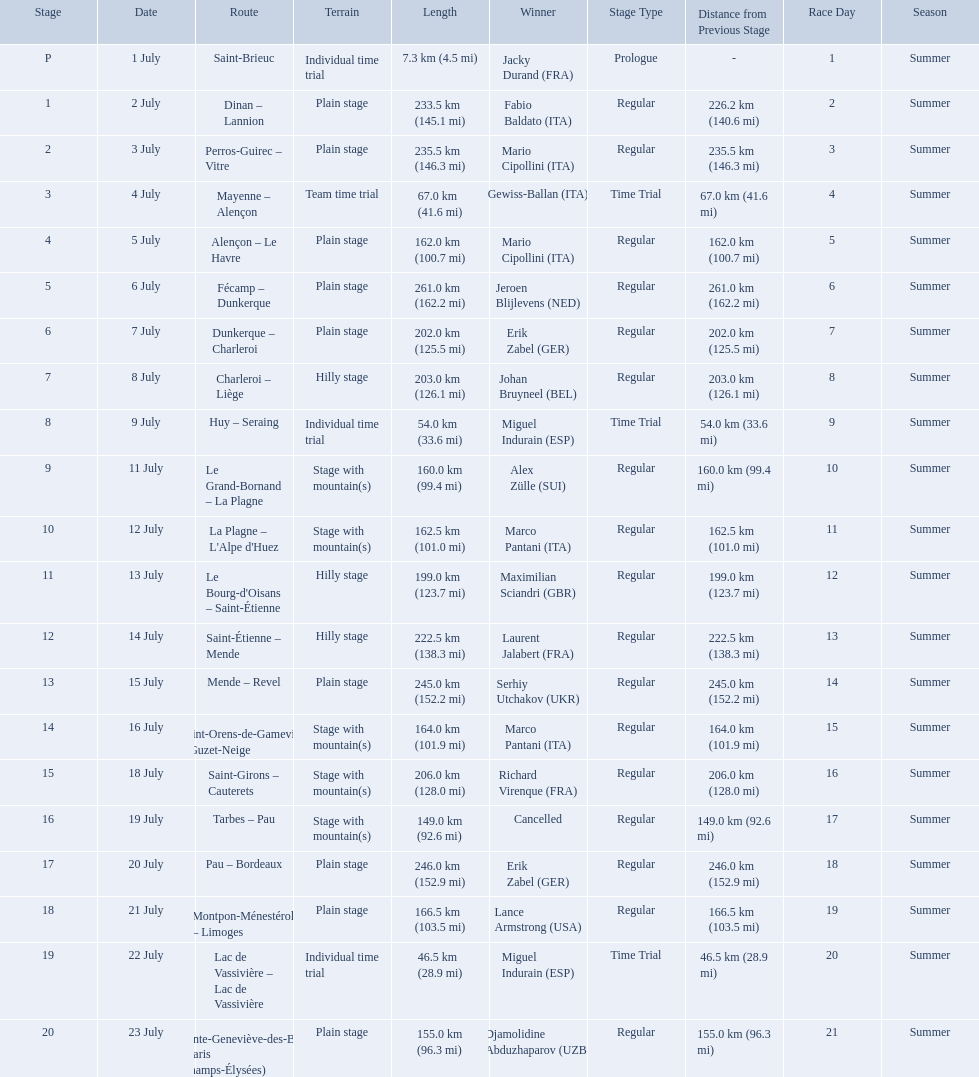What were the lengths of all the stages of the 1995 tour de france? 7.3 km (4.5 mi), 233.5 km (145.1 mi), 235.5 km (146.3 mi), 67.0 km (41.6 mi), 162.0 km (100.7 mi), 261.0 km (162.2 mi), 202.0 km (125.5 mi), 203.0 km (126.1 mi), 54.0 km (33.6 mi), 160.0 km (99.4 mi), 162.5 km (101.0 mi), 199.0 km (123.7 mi), 222.5 km (138.3 mi), 245.0 km (152.2 mi), 164.0 km (101.9 mi), 206.0 km (128.0 mi), 149.0 km (92.6 mi), 246.0 km (152.9 mi), 166.5 km (103.5 mi), 46.5 km (28.9 mi), 155.0 km (96.3 mi). Of those, which one occurred on july 8th? 203.0 km (126.1 mi). 